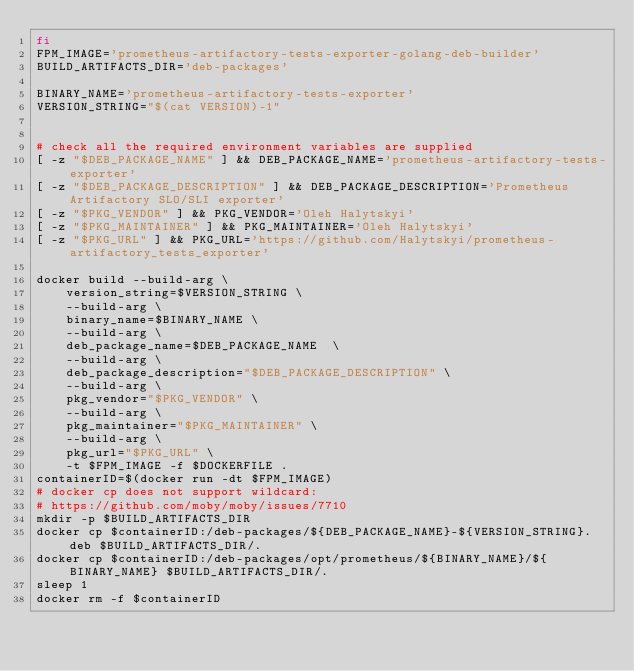<code> <loc_0><loc_0><loc_500><loc_500><_Bash_>fi
FPM_IMAGE='prometheus-artifactory-tests-exporter-golang-deb-builder'
BUILD_ARTIFACTS_DIR='deb-packages'

BINARY_NAME='prometheus-artifactory-tests-exporter'
VERSION_STRING="$(cat VERSION)-1"


# check all the required environment variables are supplied
[ -z "$DEB_PACKAGE_NAME" ] && DEB_PACKAGE_NAME='prometheus-artifactory-tests-exporter'
[ -z "$DEB_PACKAGE_DESCRIPTION" ] && DEB_PACKAGE_DESCRIPTION='Prometheus Artifactory SLO/SLI exporter'
[ -z "$PKG_VENDOR" ] && PKG_VENDOR='Oleh Halytskyi'
[ -z "$PKG_MAINTAINER" ] && PKG_MAINTAINER='Oleh Halytskyi'
[ -z "$PKG_URL" ] && PKG_URL='https://github.com/Halytskyi/prometheus-artifactory_tests_exporter'

docker build --build-arg \
    version_string=$VERSION_STRING \
    --build-arg \
    binary_name=$BINARY_NAME \
    --build-arg \
    deb_package_name=$DEB_PACKAGE_NAME  \
    --build-arg \
    deb_package_description="$DEB_PACKAGE_DESCRIPTION" \
    --build-arg \
    pkg_vendor="$PKG_VENDOR" \
    --build-arg \
    pkg_maintainer="$PKG_MAINTAINER" \
    --build-arg \
    pkg_url="$PKG_URL" \
    -t $FPM_IMAGE -f $DOCKERFILE .
containerID=$(docker run -dt $FPM_IMAGE)
# docker cp does not support wildcard:
# https://github.com/moby/moby/issues/7710
mkdir -p $BUILD_ARTIFACTS_DIR
docker cp $containerID:/deb-packages/${DEB_PACKAGE_NAME}-${VERSION_STRING}.deb $BUILD_ARTIFACTS_DIR/.
docker cp $containerID:/deb-packages/opt/prometheus/${BINARY_NAME}/${BINARY_NAME} $BUILD_ARTIFACTS_DIR/.
sleep 1
docker rm -f $containerID
</code> 